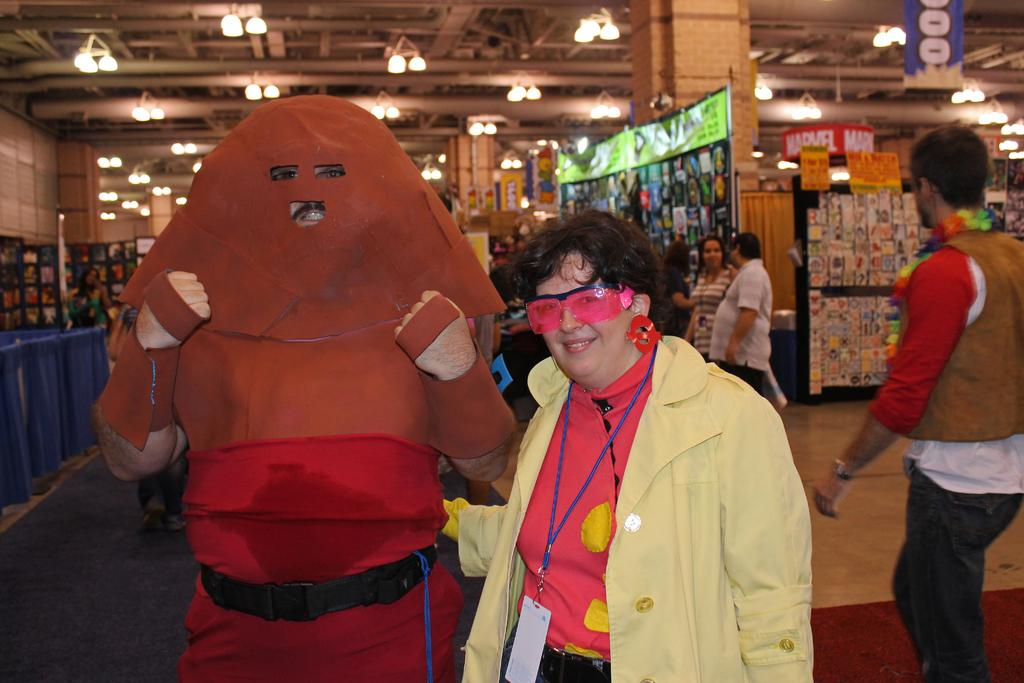What is the main subject of the image? The main subject of the image is a woman. Can you describe the appearance of another person in the image? There is a person wearing a costume in the image. How are the woman and the person wearing a costume positioned in relation to each other? The woman is standing beside the person wearing a costume. What type of weather can be seen in the image? There is no information about the weather in the image, as it focuses on the woman and the person wearing a costume. Can you tell me how many parents are visible in the image? There is no reference to a parent in the image. What is the woman using to drink in the image? There is no straw or any indication of drinking in the image. 